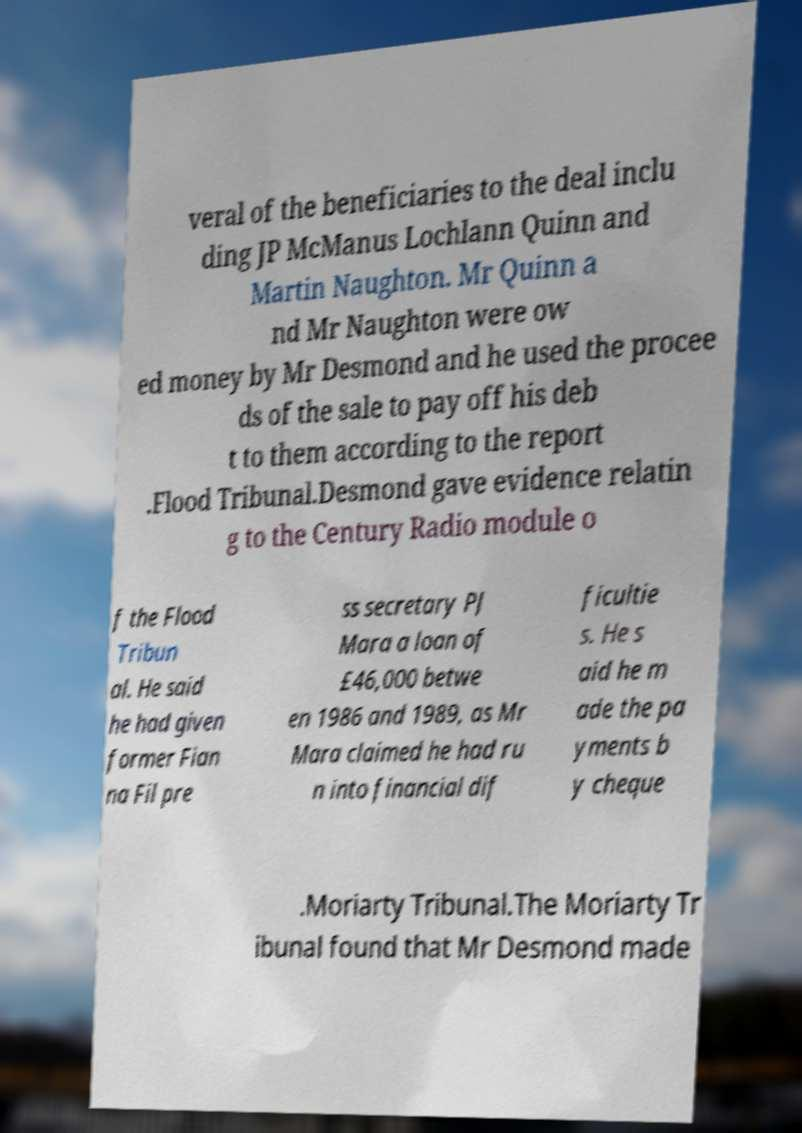I need the written content from this picture converted into text. Can you do that? veral of the beneficiaries to the deal inclu ding JP McManus Lochlann Quinn and Martin Naughton. Mr Quinn a nd Mr Naughton were ow ed money by Mr Desmond and he used the procee ds of the sale to pay off his deb t to them according to the report .Flood Tribunal.Desmond gave evidence relatin g to the Century Radio module o f the Flood Tribun al. He said he had given former Fian na Fil pre ss secretary PJ Mara a loan of £46,000 betwe en 1986 and 1989, as Mr Mara claimed he had ru n into financial dif ficultie s. He s aid he m ade the pa yments b y cheque .Moriarty Tribunal.The Moriarty Tr ibunal found that Mr Desmond made 